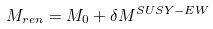<formula> <loc_0><loc_0><loc_500><loc_500>M _ { r e n } = M _ { 0 } + \delta M ^ { S U S Y - E W }</formula> 